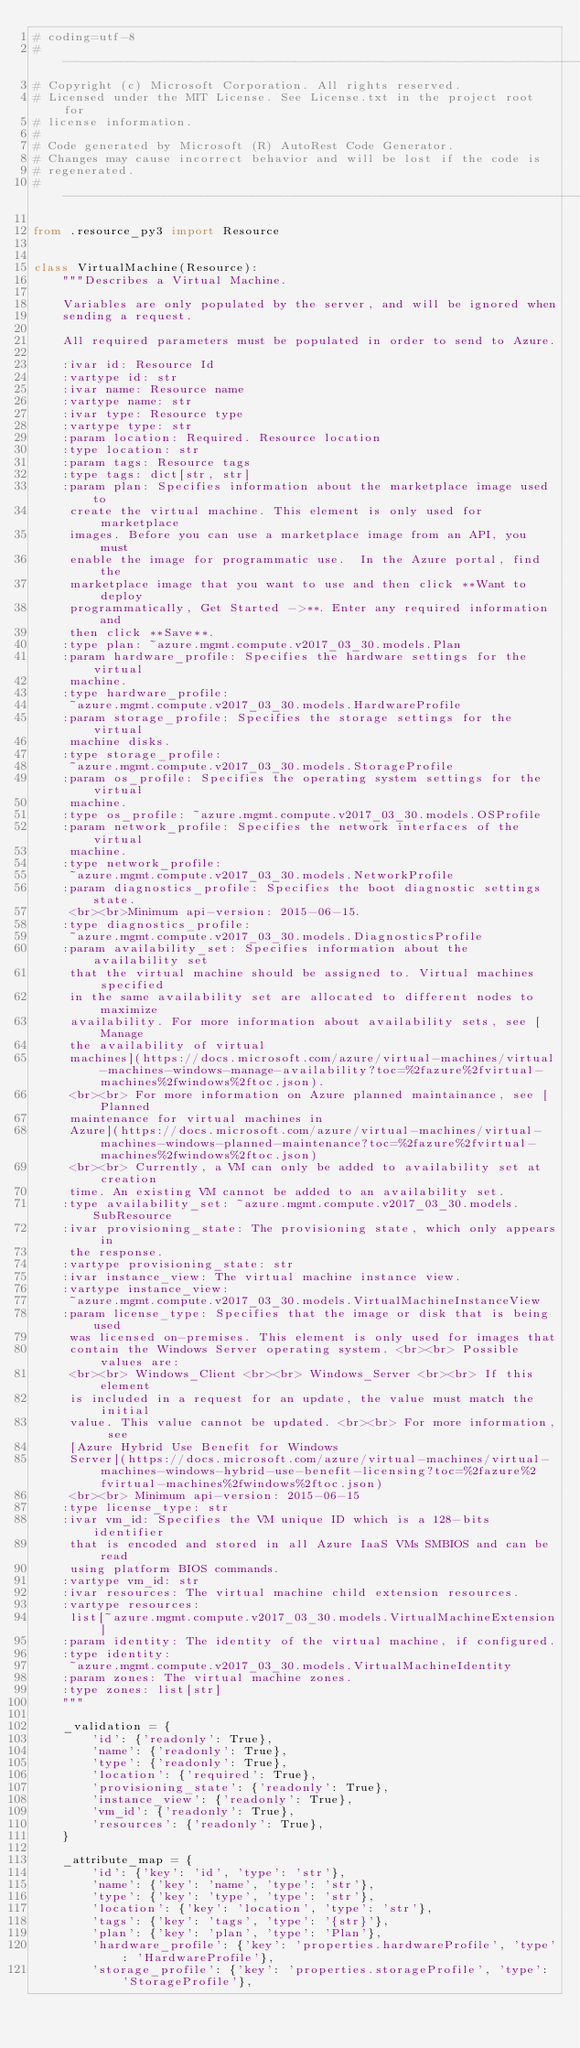<code> <loc_0><loc_0><loc_500><loc_500><_Python_># coding=utf-8
# --------------------------------------------------------------------------
# Copyright (c) Microsoft Corporation. All rights reserved.
# Licensed under the MIT License. See License.txt in the project root for
# license information.
#
# Code generated by Microsoft (R) AutoRest Code Generator.
# Changes may cause incorrect behavior and will be lost if the code is
# regenerated.
# --------------------------------------------------------------------------

from .resource_py3 import Resource


class VirtualMachine(Resource):
    """Describes a Virtual Machine.

    Variables are only populated by the server, and will be ignored when
    sending a request.

    All required parameters must be populated in order to send to Azure.

    :ivar id: Resource Id
    :vartype id: str
    :ivar name: Resource name
    :vartype name: str
    :ivar type: Resource type
    :vartype type: str
    :param location: Required. Resource location
    :type location: str
    :param tags: Resource tags
    :type tags: dict[str, str]
    :param plan: Specifies information about the marketplace image used to
     create the virtual machine. This element is only used for marketplace
     images. Before you can use a marketplace image from an API, you must
     enable the image for programmatic use.  In the Azure portal, find the
     marketplace image that you want to use and then click **Want to deploy
     programmatically, Get Started ->**. Enter any required information and
     then click **Save**.
    :type plan: ~azure.mgmt.compute.v2017_03_30.models.Plan
    :param hardware_profile: Specifies the hardware settings for the virtual
     machine.
    :type hardware_profile:
     ~azure.mgmt.compute.v2017_03_30.models.HardwareProfile
    :param storage_profile: Specifies the storage settings for the virtual
     machine disks.
    :type storage_profile:
     ~azure.mgmt.compute.v2017_03_30.models.StorageProfile
    :param os_profile: Specifies the operating system settings for the virtual
     machine.
    :type os_profile: ~azure.mgmt.compute.v2017_03_30.models.OSProfile
    :param network_profile: Specifies the network interfaces of the virtual
     machine.
    :type network_profile:
     ~azure.mgmt.compute.v2017_03_30.models.NetworkProfile
    :param diagnostics_profile: Specifies the boot diagnostic settings state.
     <br><br>Minimum api-version: 2015-06-15.
    :type diagnostics_profile:
     ~azure.mgmt.compute.v2017_03_30.models.DiagnosticsProfile
    :param availability_set: Specifies information about the availability set
     that the virtual machine should be assigned to. Virtual machines specified
     in the same availability set are allocated to different nodes to maximize
     availability. For more information about availability sets, see [Manage
     the availability of virtual
     machines](https://docs.microsoft.com/azure/virtual-machines/virtual-machines-windows-manage-availability?toc=%2fazure%2fvirtual-machines%2fwindows%2ftoc.json).
     <br><br> For more information on Azure planned maintainance, see [Planned
     maintenance for virtual machines in
     Azure](https://docs.microsoft.com/azure/virtual-machines/virtual-machines-windows-planned-maintenance?toc=%2fazure%2fvirtual-machines%2fwindows%2ftoc.json)
     <br><br> Currently, a VM can only be added to availability set at creation
     time. An existing VM cannot be added to an availability set.
    :type availability_set: ~azure.mgmt.compute.v2017_03_30.models.SubResource
    :ivar provisioning_state: The provisioning state, which only appears in
     the response.
    :vartype provisioning_state: str
    :ivar instance_view: The virtual machine instance view.
    :vartype instance_view:
     ~azure.mgmt.compute.v2017_03_30.models.VirtualMachineInstanceView
    :param license_type: Specifies that the image or disk that is being used
     was licensed on-premises. This element is only used for images that
     contain the Windows Server operating system. <br><br> Possible values are:
     <br><br> Windows_Client <br><br> Windows_Server <br><br> If this element
     is included in a request for an update, the value must match the initial
     value. This value cannot be updated. <br><br> For more information, see
     [Azure Hybrid Use Benefit for Windows
     Server](https://docs.microsoft.com/azure/virtual-machines/virtual-machines-windows-hybrid-use-benefit-licensing?toc=%2fazure%2fvirtual-machines%2fwindows%2ftoc.json)
     <br><br> Minimum api-version: 2015-06-15
    :type license_type: str
    :ivar vm_id: Specifies the VM unique ID which is a 128-bits identifier
     that is encoded and stored in all Azure IaaS VMs SMBIOS and can be read
     using platform BIOS commands.
    :vartype vm_id: str
    :ivar resources: The virtual machine child extension resources.
    :vartype resources:
     list[~azure.mgmt.compute.v2017_03_30.models.VirtualMachineExtension]
    :param identity: The identity of the virtual machine, if configured.
    :type identity:
     ~azure.mgmt.compute.v2017_03_30.models.VirtualMachineIdentity
    :param zones: The virtual machine zones.
    :type zones: list[str]
    """

    _validation = {
        'id': {'readonly': True},
        'name': {'readonly': True},
        'type': {'readonly': True},
        'location': {'required': True},
        'provisioning_state': {'readonly': True},
        'instance_view': {'readonly': True},
        'vm_id': {'readonly': True},
        'resources': {'readonly': True},
    }

    _attribute_map = {
        'id': {'key': 'id', 'type': 'str'},
        'name': {'key': 'name', 'type': 'str'},
        'type': {'key': 'type', 'type': 'str'},
        'location': {'key': 'location', 'type': 'str'},
        'tags': {'key': 'tags', 'type': '{str}'},
        'plan': {'key': 'plan', 'type': 'Plan'},
        'hardware_profile': {'key': 'properties.hardwareProfile', 'type': 'HardwareProfile'},
        'storage_profile': {'key': 'properties.storageProfile', 'type': 'StorageProfile'},</code> 